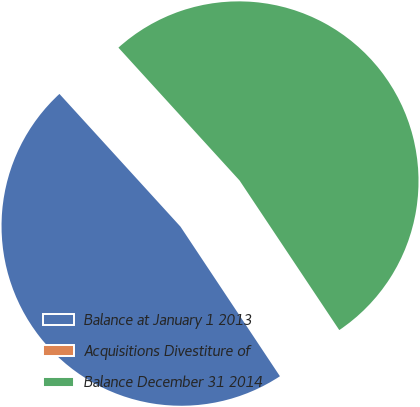Convert chart to OTSL. <chart><loc_0><loc_0><loc_500><loc_500><pie_chart><fcel>Balance at January 1 2013<fcel>Acquisitions Divestiture of<fcel>Balance December 31 2014<nl><fcel>47.57%<fcel>0.02%<fcel>52.41%<nl></chart> 